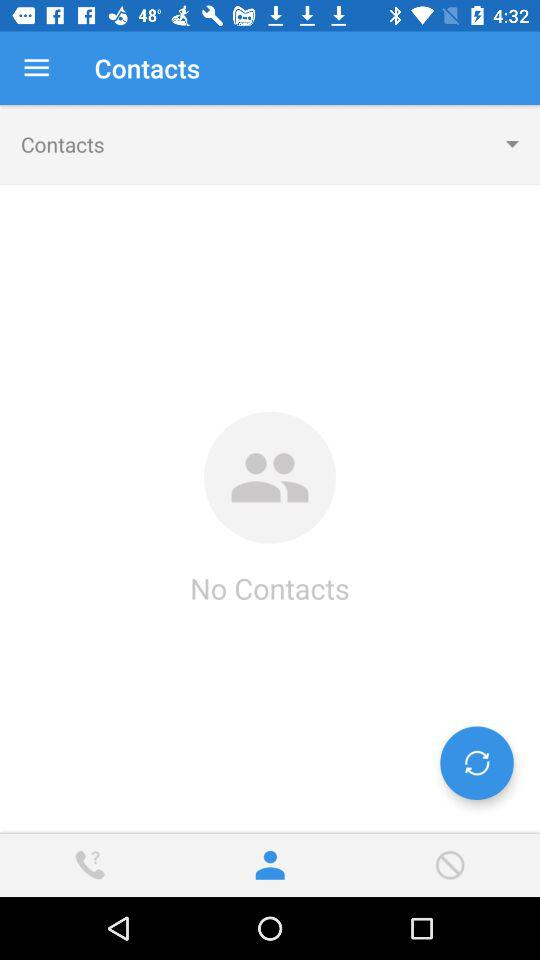What tab is selected? The selected tab is contacts. 